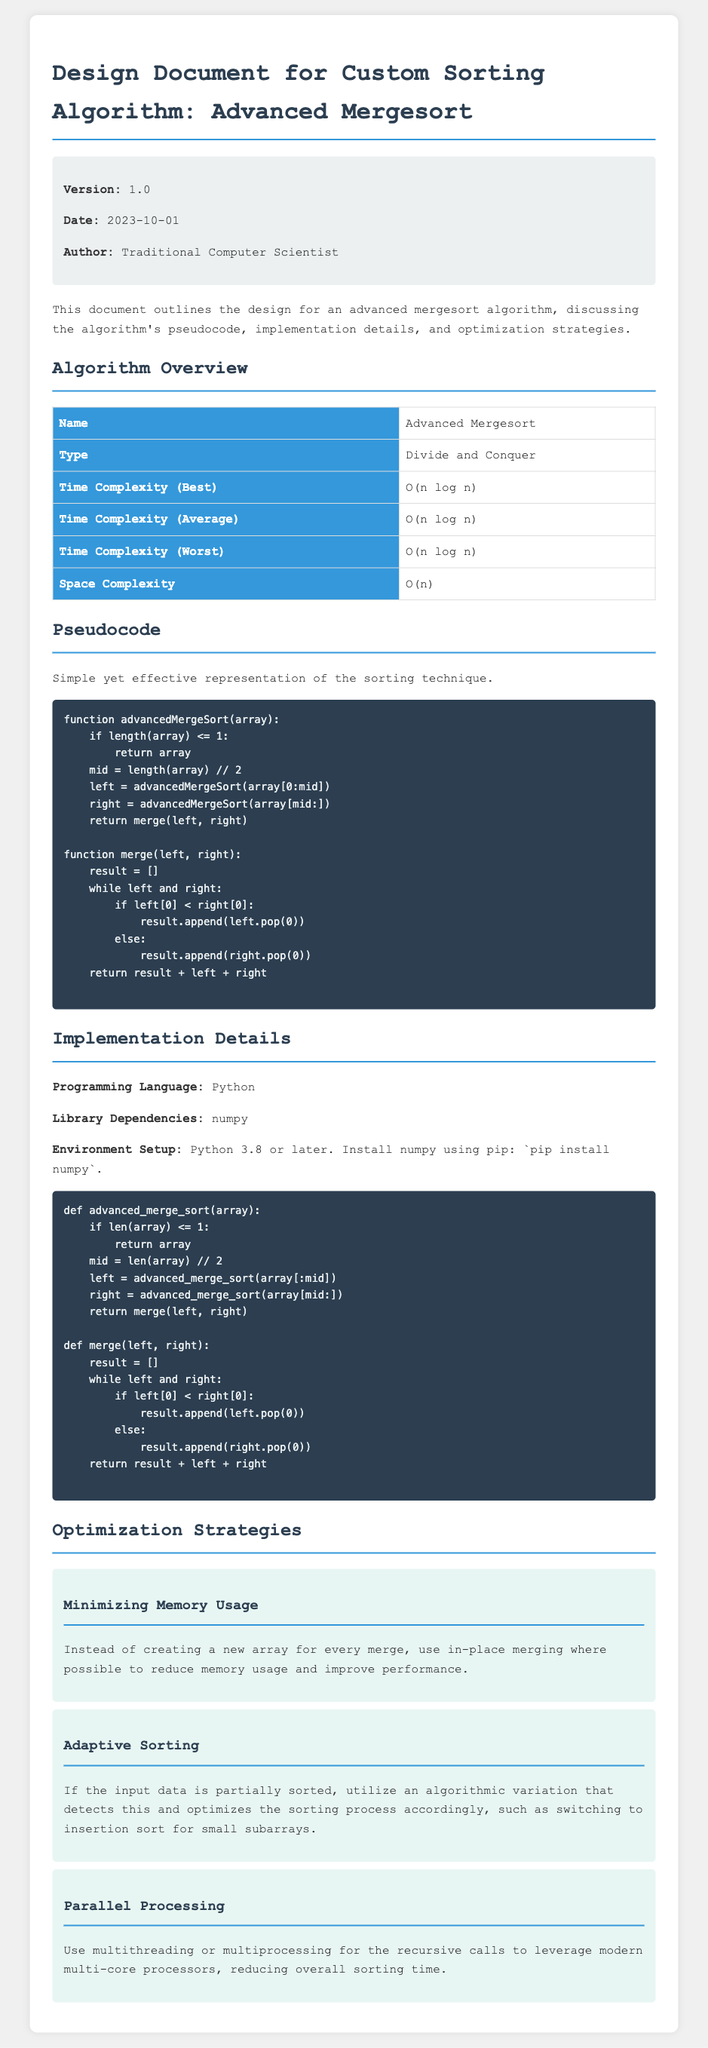What is the name of the sorting algorithm? The name of the sorting algorithm is specified under 'Algorithm Overview' in the document.
Answer: Advanced Mergesort What is the time complexity in the worst case? The time complexity for the worst case is summarized in the 'Algorithm Overview' table.
Answer: O(n log n) What programming language is used for implementation? The programming language used for implementation is mentioned in the 'Implementation Details' section.
Answer: Python What version of the document is indicated? The version of the document is noted in the 'Metadata' section at the top.
Answer: 1.0 What is one of the optimization strategies mentioned? The optimization strategies are listed in the 'Optimization Strategies' section, requesting a specific strategy.
Answer: Minimizing Memory Usage How does the algorithm handle partially sorted input? The document provides detail on how the algorithm adapts for partially sorted data in one of the optimization strategies.
Answer: Adaptive Sorting Which library is required to run the implementation? The required library for the implementation is specified in the 'Implementation Details' section.
Answer: numpy What date was the document authored? The date can be found in the 'Metadata' section, which outlines key information about the document.
Answer: 2023-10-01 What is the space complexity of the algorithm? The space complexity is provided in the 'Algorithm Overview' table, which summarizes the algorithm specifics.
Answer: O(n) 